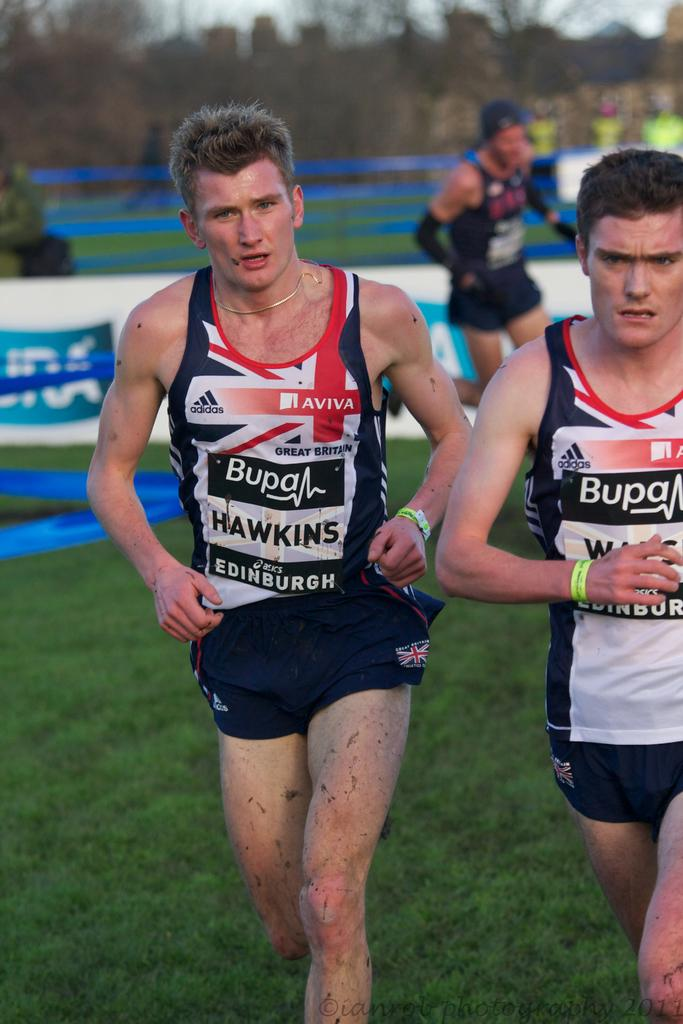<image>
Summarize the visual content of the image. Two runners one named Hawkins running in Edinburgh. 